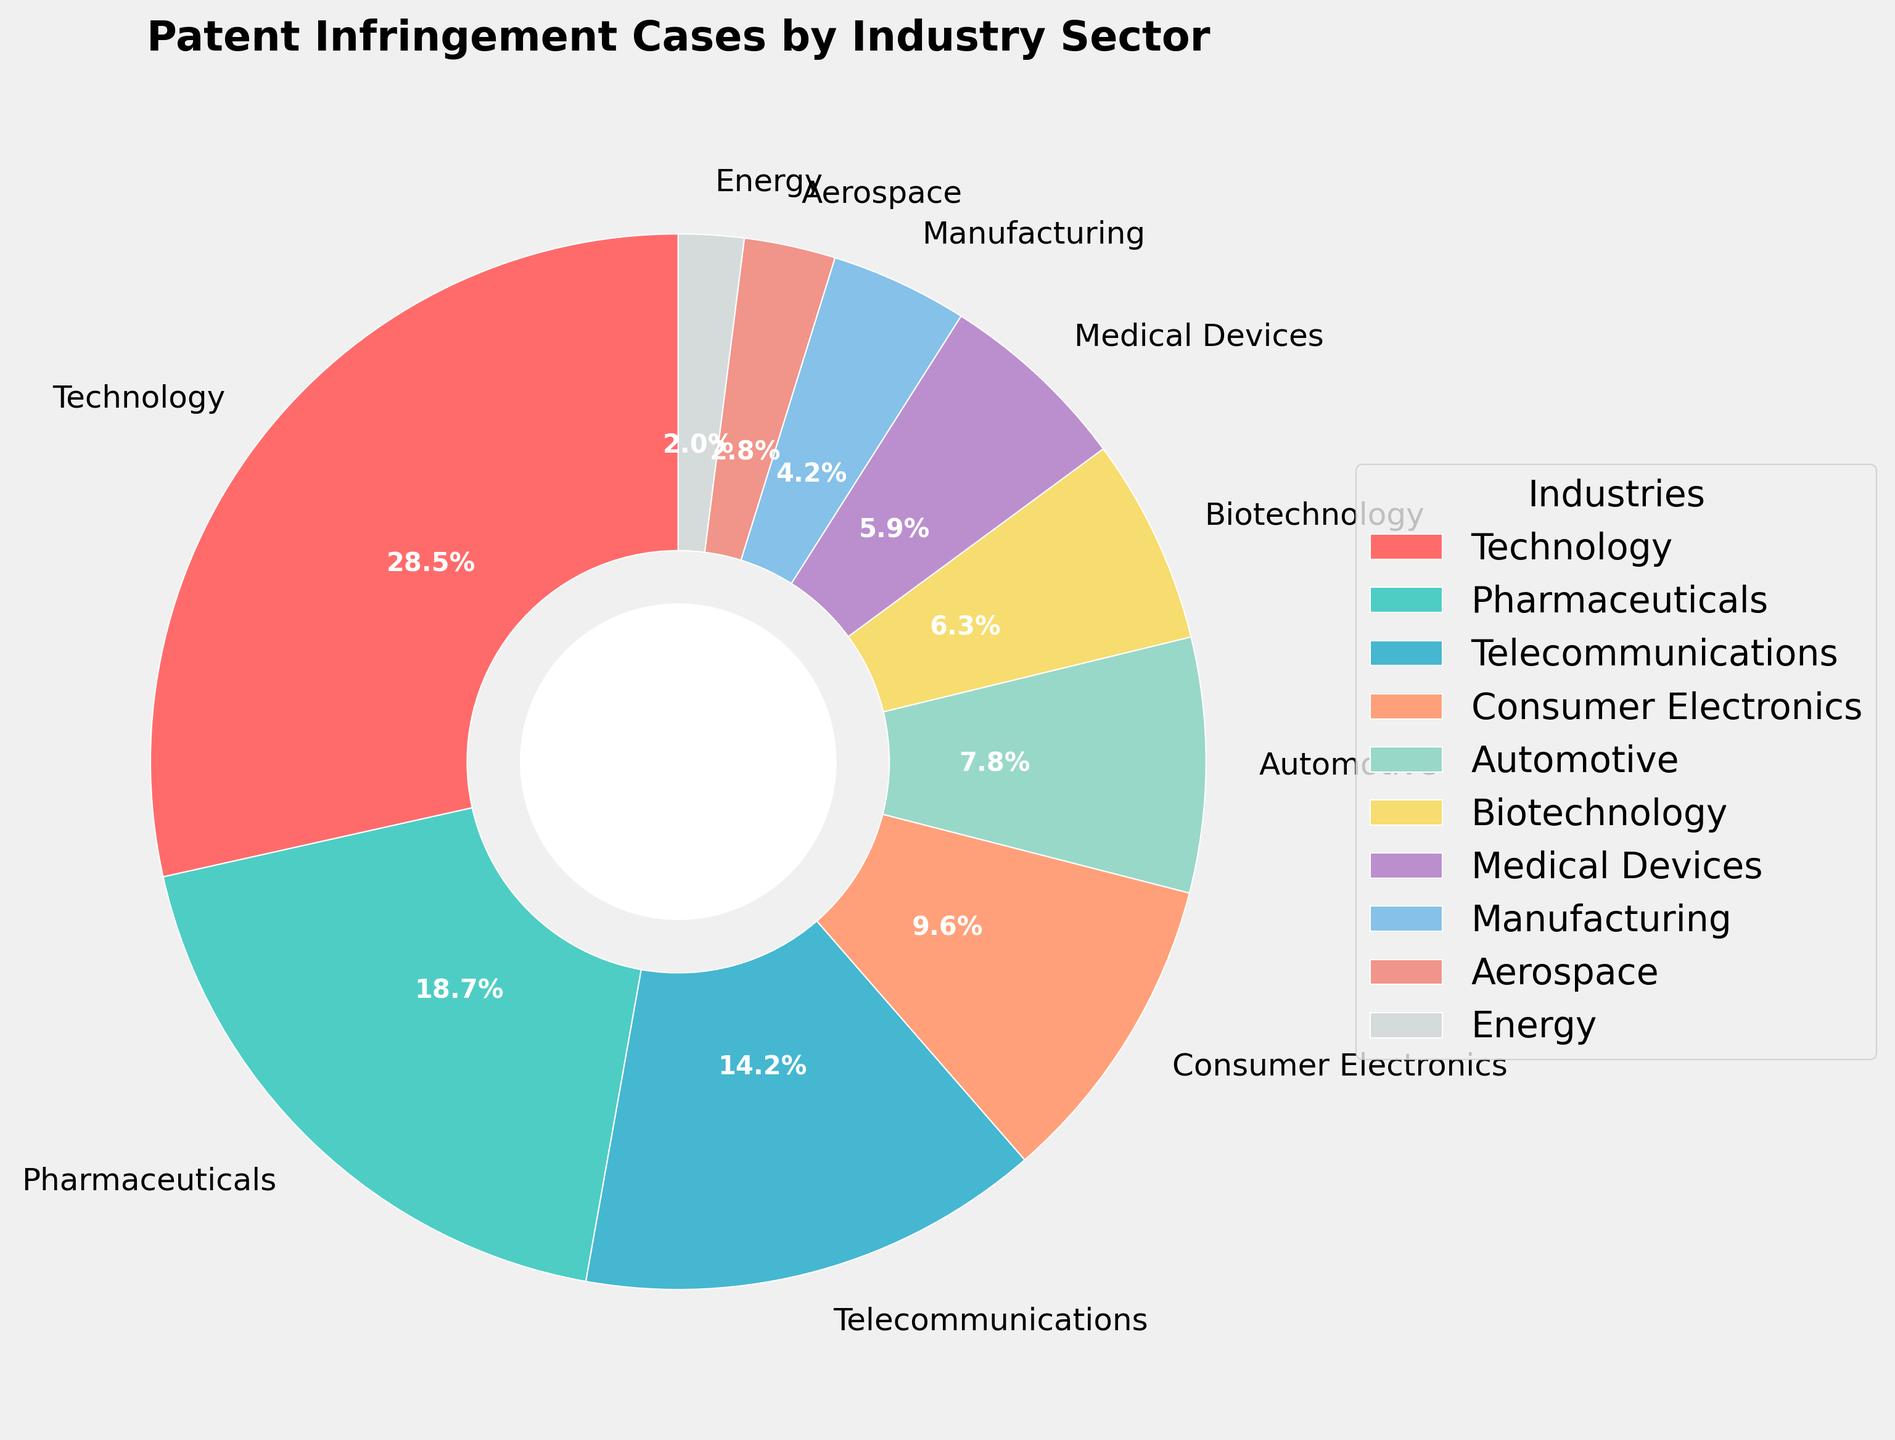Which industry sector accounts for the highest percentage of patent infringement cases? By inspecting the pie chart, it is clear that the Technology sector has the largest wedge, which is labeled with 28.5%.
Answer: Technology What is the combined percentage of patent infringement cases in the Technology and Pharmaceuticals sectors? The percentages for the Technology and Pharmaceuticals sectors are 28.5% and 18.7%, respectively. Adding these values together gives 28.5% + 18.7% = 47.2%.
Answer: 47.2% Which sectors combined account for less than 10% of patent infringement cases? The Energy and Aerospace sectors are labeled with 2.0% and 2.8%, respectively. Adding these values together gives 2.0% + 2.8% = 4.8%, which is less than 10%.
Answer: Energy and Aerospace Which industry sector has a higher percentage of patent infringement cases, Consumer Electronics or Biotechnology? By comparing the wedges labeled for Consumer Electronics (9.6%) and Biotechnology (6.3%), it is evident that Consumer Electronics has a higher percentage.
Answer: Consumer Electronics What is the difference in percentage points between the Telecommunications and Automotive sectors? The percentage for the Telecommunications sector is 14.2%, while the Automotive sector accounts for 7.8%. The difference is 14.2% - 7.8% = 6.4%.
Answer: 6.4% What is the combined percentage of the three sectors with the smallest shares of patent infringement cases? The three smallest sectors are Energy (2.0%), Aerospace (2.8%), and Manufacturing (4.2%). Adding these values together gives 2.0% + 2.8% + 4.2% = 9.0%.
Answer: 9.0% How much greater is the percentage of patent infringement cases in the Pharmaceuticals sector compared to the Medical Devices sector? The Pharmaceuticals sector has 18.7% of the cases, while the Medical Devices sector has 5.9%. The difference is 18.7% - 5.9% = 12.8%.
Answer: 12.8% Which industry sector is represented by the green color wedge in the pie chart? According to the custom color palette provided in the code, the green-colored wedge represents the Pharmaceuticals sector with 18.7%.
Answer: Pharmaceuticals 